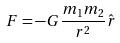<formula> <loc_0><loc_0><loc_500><loc_500>F = - G \frac { m _ { 1 } m _ { 2 } } { r ^ { 2 } } \hat { r }</formula> 